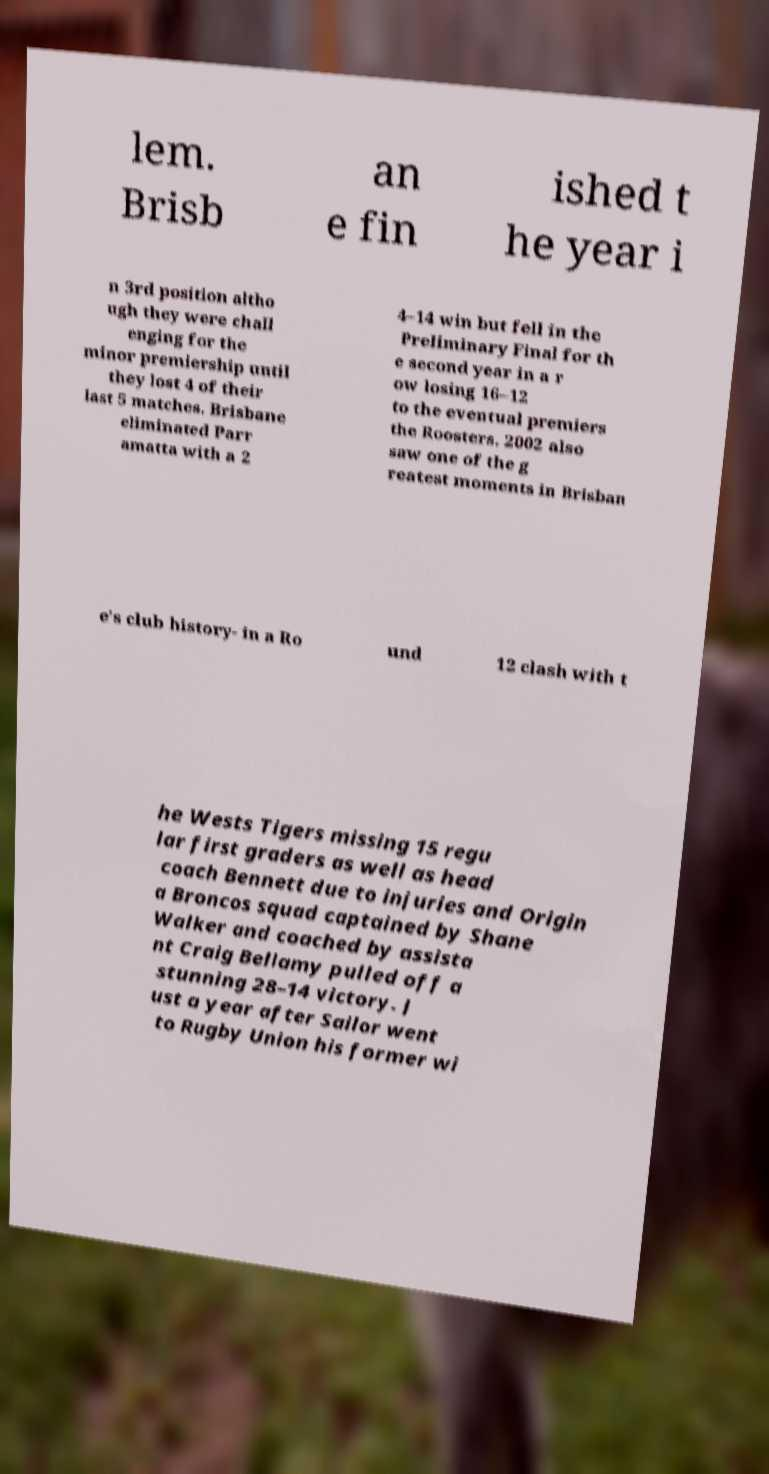For documentation purposes, I need the text within this image transcribed. Could you provide that? lem. Brisb an e fin ished t he year i n 3rd position altho ugh they were chall enging for the minor premiership until they lost 4 of their last 5 matches. Brisbane eliminated Parr amatta with a 2 4–14 win but fell in the Preliminary Final for th e second year in a r ow losing 16–12 to the eventual premiers the Roosters. 2002 also saw one of the g reatest moments in Brisban e's club history- in a Ro und 12 clash with t he Wests Tigers missing 15 regu lar first graders as well as head coach Bennett due to injuries and Origin a Broncos squad captained by Shane Walker and coached by assista nt Craig Bellamy pulled off a stunning 28–14 victory. J ust a year after Sailor went to Rugby Union his former wi 